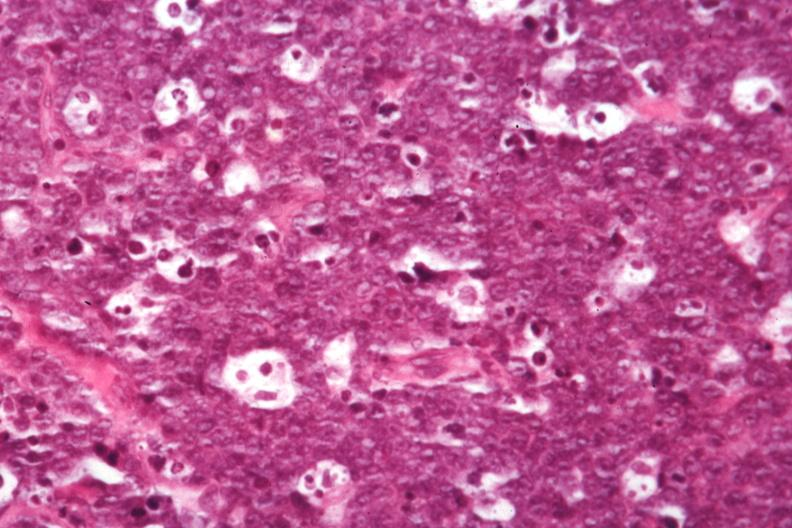s lymph node present?
Answer the question using a single word or phrase. Yes 